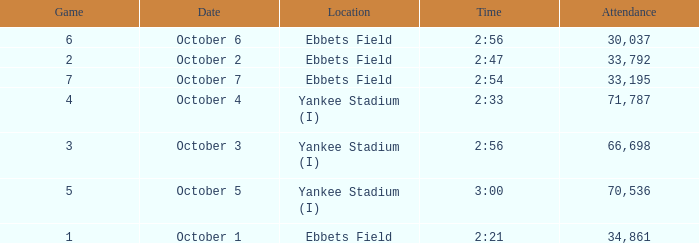The game of 6 has what lowest attendance? 30037.0. 